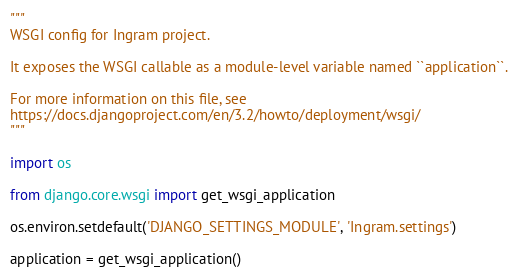Convert code to text. <code><loc_0><loc_0><loc_500><loc_500><_Python_>"""
WSGI config for Ingram project.

It exposes the WSGI callable as a module-level variable named ``application``.

For more information on this file, see
https://docs.djangoproject.com/en/3.2/howto/deployment/wsgi/
"""

import os

from django.core.wsgi import get_wsgi_application

os.environ.setdefault('DJANGO_SETTINGS_MODULE', 'Ingram.settings')

application = get_wsgi_application()
</code> 